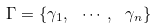<formula> <loc_0><loc_0><loc_500><loc_500>\Gamma = \{ \gamma _ { 1 } , \ \cdots , \ \gamma _ { n } \}</formula> 